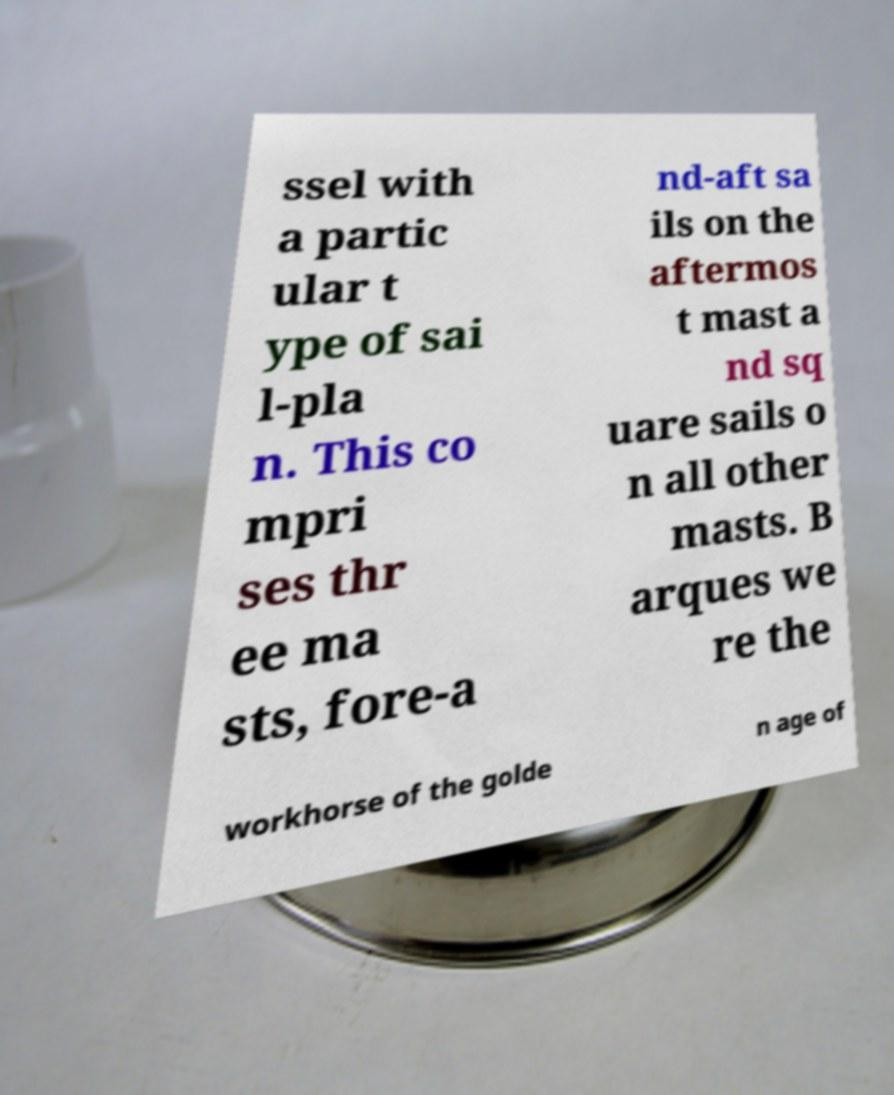For documentation purposes, I need the text within this image transcribed. Could you provide that? ssel with a partic ular t ype of sai l-pla n. This co mpri ses thr ee ma sts, fore-a nd-aft sa ils on the aftermos t mast a nd sq uare sails o n all other masts. B arques we re the workhorse of the golde n age of 